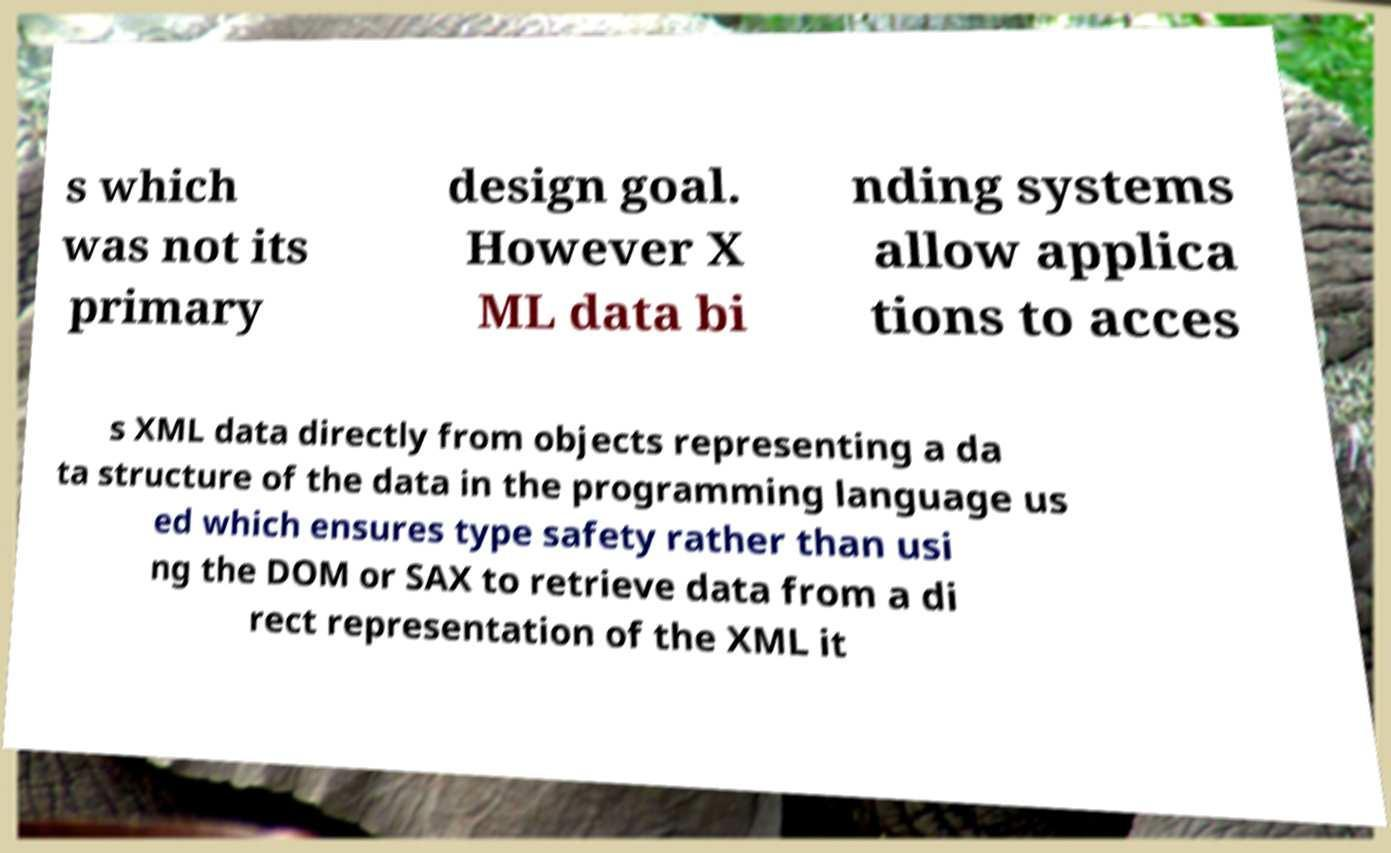Please read and relay the text visible in this image. What does it say? s which was not its primary design goal. However X ML data bi nding systems allow applica tions to acces s XML data directly from objects representing a da ta structure of the data in the programming language us ed which ensures type safety rather than usi ng the DOM or SAX to retrieve data from a di rect representation of the XML it 